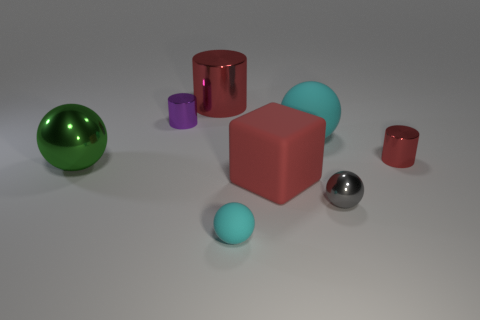There is a big cylinder that is the same color as the big block; what material is it?
Give a very brief answer. Metal. Are there fewer big objects that are left of the purple object than big things behind the big green sphere?
Provide a short and direct response. Yes. There is another cyan object that is the same shape as the big cyan rubber object; what size is it?
Give a very brief answer. Small. Are there any other things that are the same size as the gray metallic ball?
Your response must be concise. Yes. What number of objects are tiny cylinders on the left side of the big matte cube or small spheres on the right side of the large green shiny ball?
Provide a succinct answer. 3. Does the purple object have the same size as the red rubber object?
Your response must be concise. No. Are there more red metallic cylinders than purple shiny cubes?
Give a very brief answer. Yes. What number of other objects are there of the same color as the rubber cube?
Make the answer very short. 2. How many objects are tiny cylinders or big green shiny balls?
Offer a very short reply. 3. Do the cyan rubber thing that is in front of the big cyan rubber ball and the small purple thing have the same shape?
Your answer should be very brief. No. 